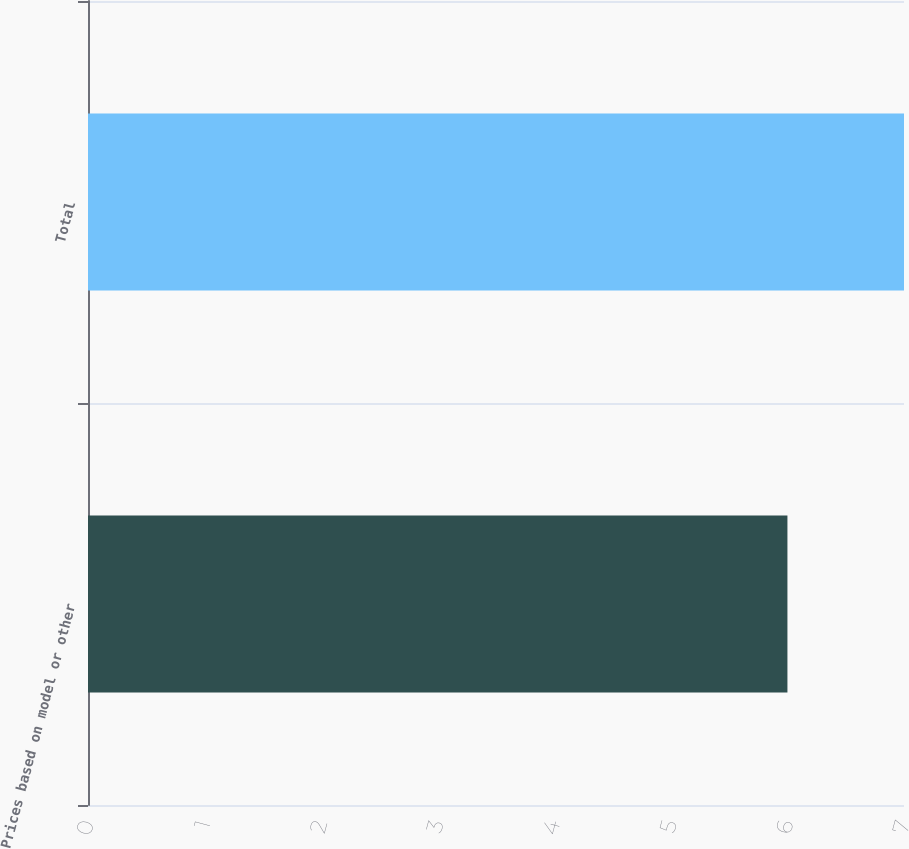Convert chart to OTSL. <chart><loc_0><loc_0><loc_500><loc_500><bar_chart><fcel>Prices based on model or other<fcel>Total<nl><fcel>6<fcel>7<nl></chart> 